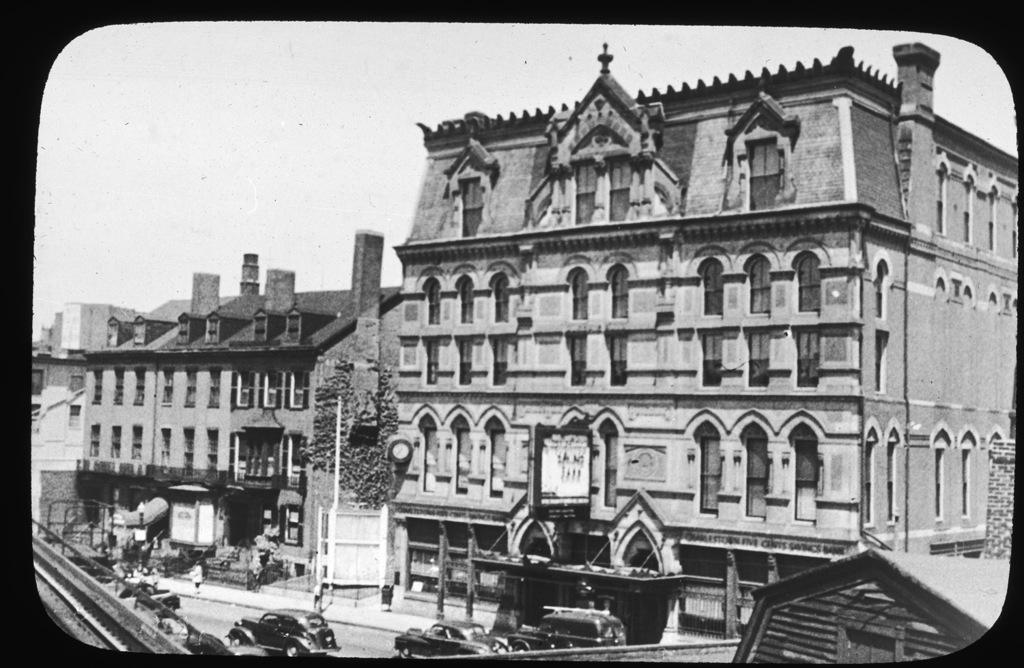Please provide a concise description of this image. In this image we can see buildings with windows. Also there is a road. On the road there are many vehicles. In the background there is sky. And this is a black and white image. 